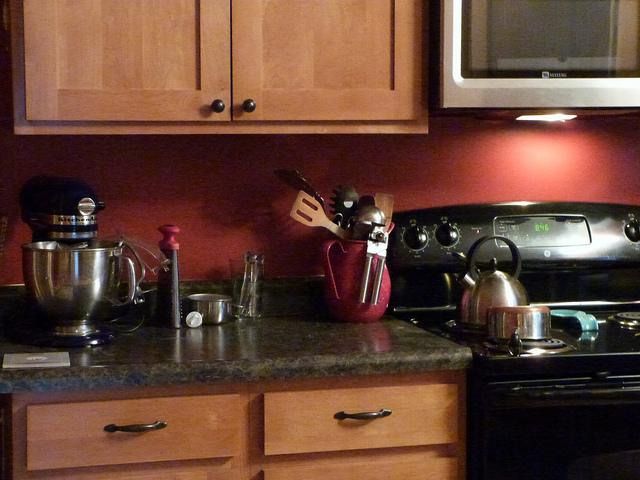What fuels the stove? electricity 